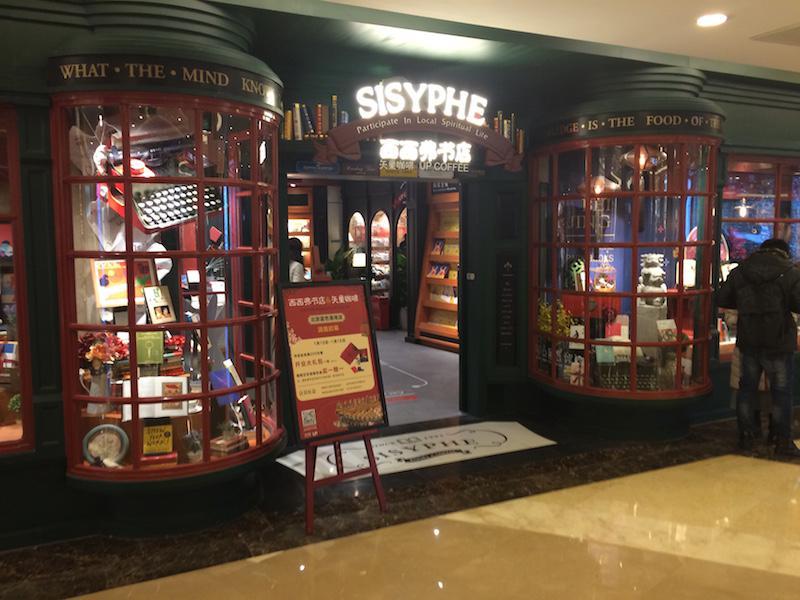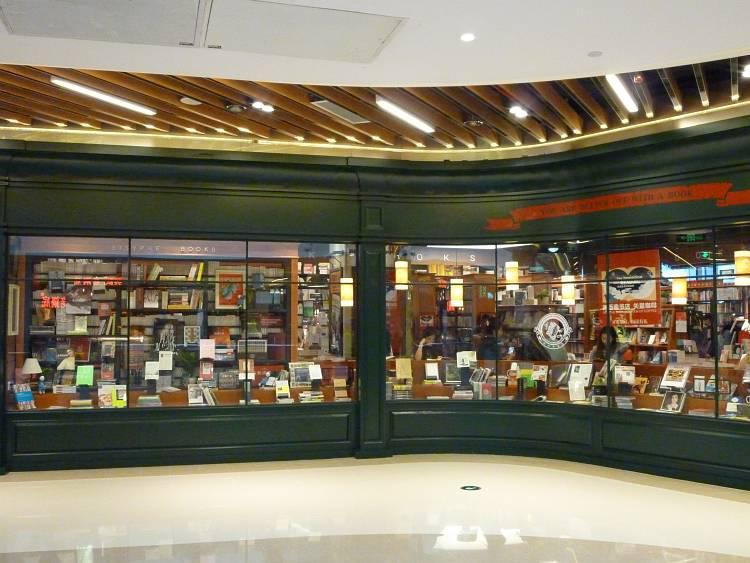The first image is the image on the left, the second image is the image on the right. For the images displayed, is the sentence "There are people sitting." factually correct? Answer yes or no. No. The first image is the image on the left, the second image is the image on the right. Considering the images on both sides, is "Each image shows the outside window of the business." valid? Answer yes or no. Yes. 